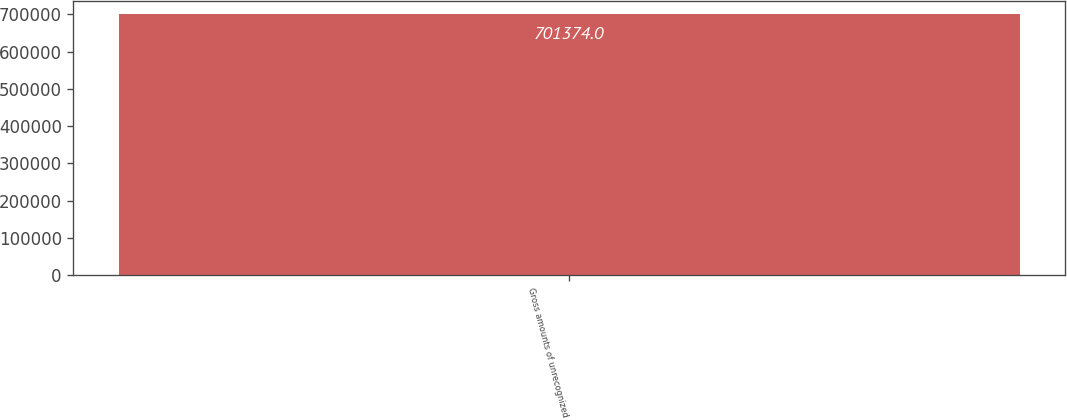Convert chart to OTSL. <chart><loc_0><loc_0><loc_500><loc_500><bar_chart><fcel>Gross amounts of unrecognized<nl><fcel>701374<nl></chart> 